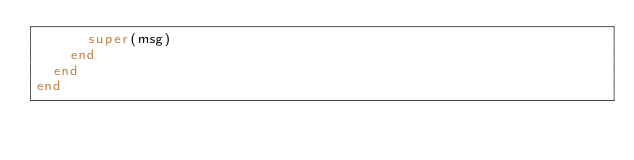Convert code to text. <code><loc_0><loc_0><loc_500><loc_500><_Ruby_>      super(msg)
    end
  end
end
</code> 